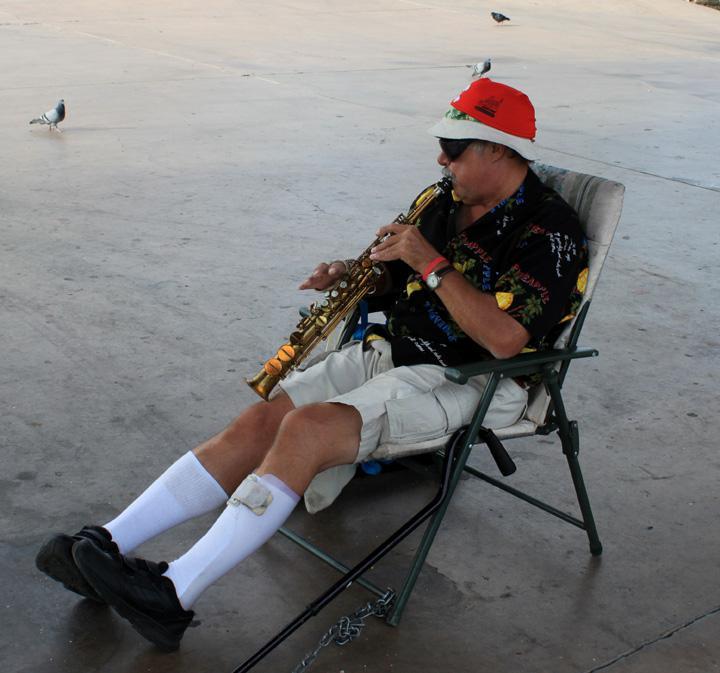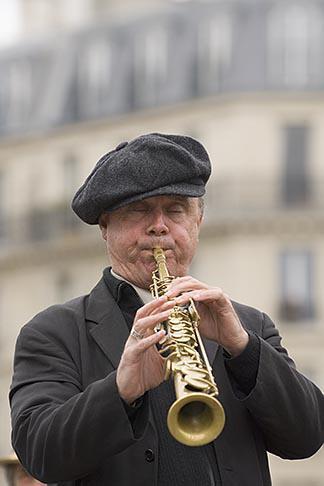The first image is the image on the left, the second image is the image on the right. Evaluate the accuracy of this statement regarding the images: "Two people are playing instruments.". Is it true? Answer yes or no. Yes. 